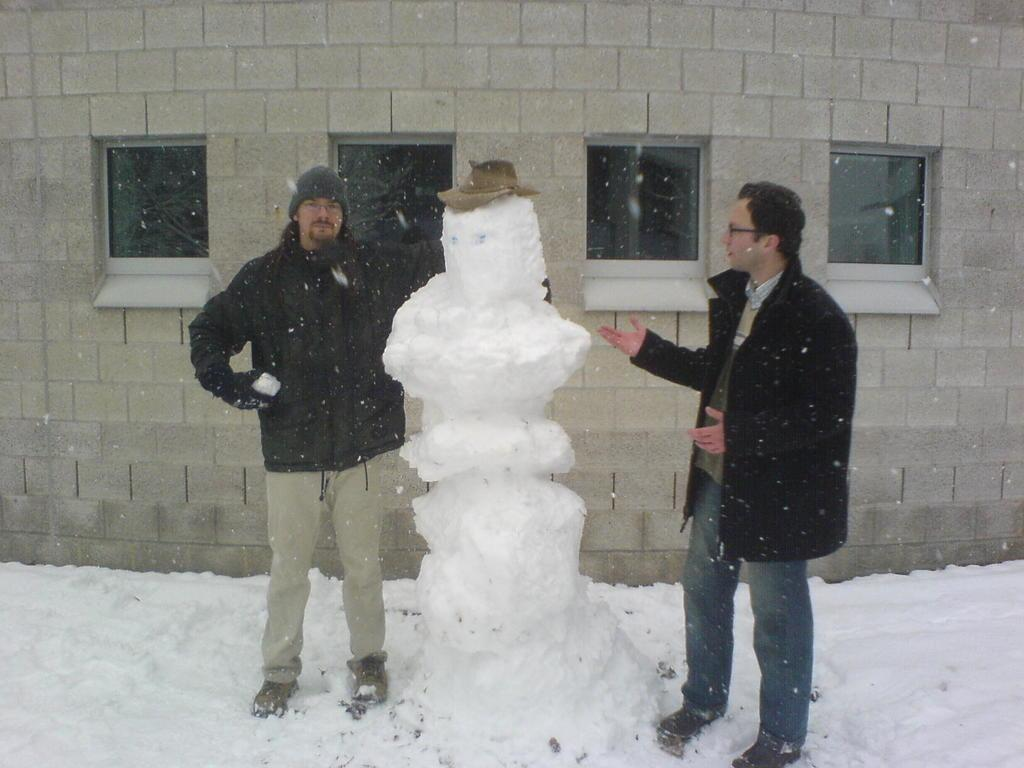How many people are present in the image? There are two persons standing in the image. What can be seen on the wall in the image? There is a wall with windows in the image. What is the weather like in the image? There is snow visible in the image, indicating a cold or wintry weather. How much money is being exchanged between the two persons in the image? There is no indication of money or any exchange taking place in the image. What type of liquid can be seen dripping from the windows in the image? There is no liquid visible on the windows in the image. 